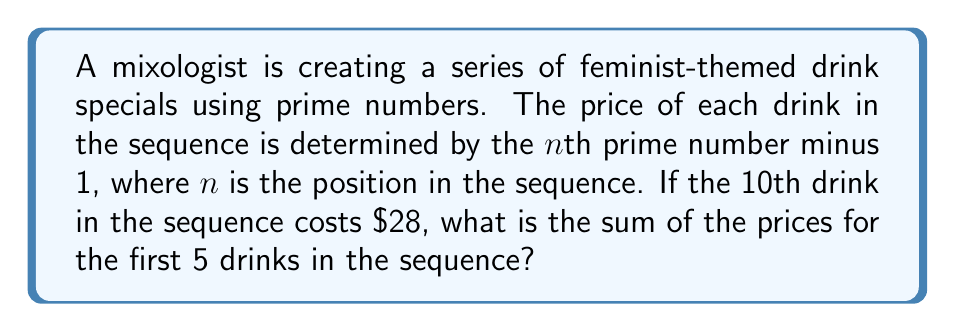Provide a solution to this math problem. Let's approach this step-by-step:

1) First, we need to identify the prime number corresponding to the 10th drink. Since its price is $28, and the price is determined by the nth prime number minus 1, we can deduce:

   $28 = p_{10} - 1$
   $p_{10} = 29$

2) Now that we know the 10th prime is 29, we can list out the first 10 prime numbers:
   2, 3, 5, 7, 11, 13, 17, 19, 23, 29

3) For our sequence, we need the first 5 primes: 2, 3, 5, 7, 11

4) Now, let's calculate the price for each of the first 5 drinks:

   1st drink: $2 - 1 = $1
   2nd drink: $3 - 1 = $2
   3rd drink: $5 - 1 = $4
   4th drink: $7 - 1 = $6
   5th drink: $11 - 1 = $10

5) To find the sum of these prices, we add them together:

   $1 + $2 + $4 + $6 + $10 = $23

Therefore, the sum of the prices for the first 5 drinks in the sequence is $23.
Answer: $23 